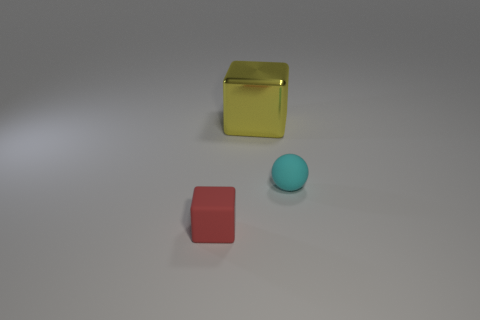What color is the other thing that is the same size as the red thing?
Ensure brevity in your answer.  Cyan. What number of shiny objects are small cyan balls or brown objects?
Give a very brief answer. 0. How many tiny rubber things are on the right side of the small object left of the metallic cube?
Offer a terse response. 1. What number of things are either big yellow objects or tiny matte objects behind the small red block?
Offer a very short reply. 2. Are there any yellow blocks that have the same material as the big object?
Provide a succinct answer. No. How many matte objects are right of the big yellow object and in front of the cyan ball?
Keep it short and to the point. 0. What is the thing that is on the left side of the yellow block made of?
Your answer should be compact. Rubber. There is another object that is made of the same material as the cyan object; what size is it?
Your answer should be compact. Small. There is a sphere; are there any small balls in front of it?
Ensure brevity in your answer.  No. What is the size of the yellow object that is the same shape as the red rubber thing?
Your response must be concise. Large. 